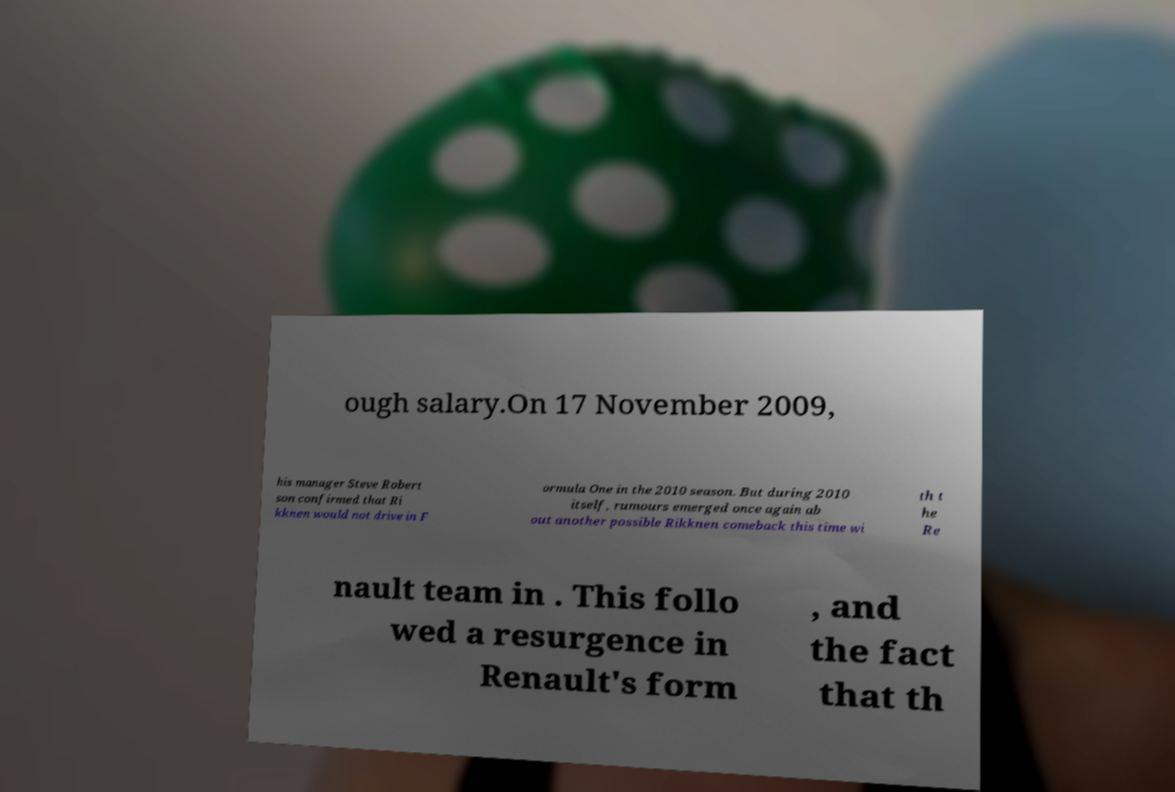Could you extract and type out the text from this image? ough salary.On 17 November 2009, his manager Steve Robert son confirmed that Ri kknen would not drive in F ormula One in the 2010 season. But during 2010 itself, rumours emerged once again ab out another possible Rikknen comeback this time wi th t he Re nault team in . This follo wed a resurgence in Renault's form , and the fact that th 